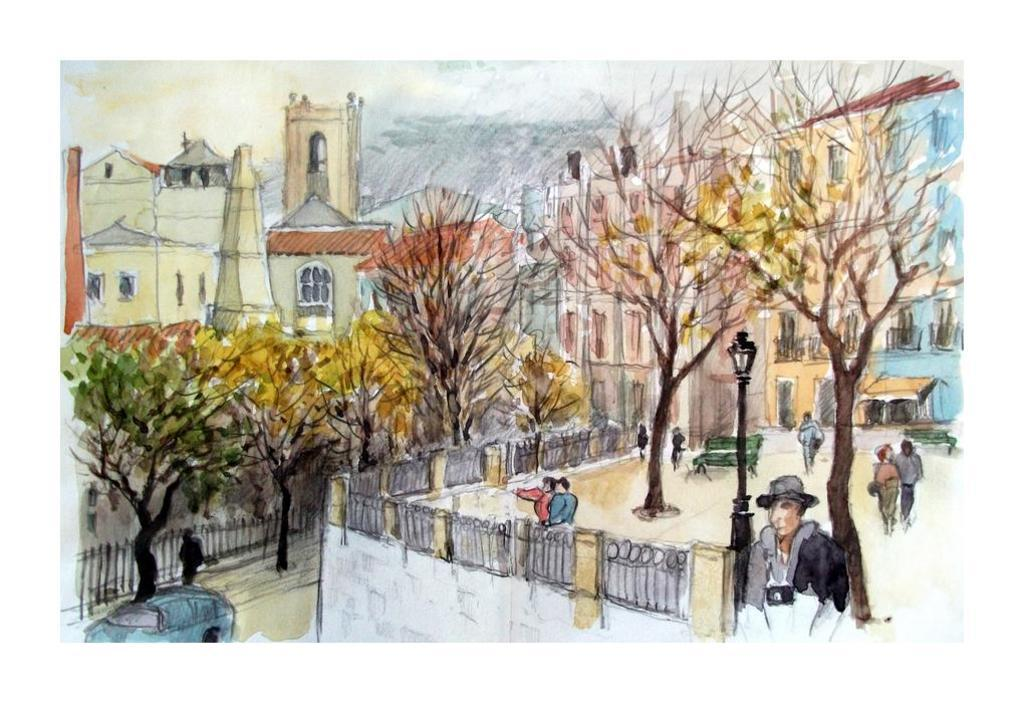What types of subjects are depicted in the painting? The painting contains people, trees, a light pole, a bench, a vehicle, buildings, and a fence. Can you describe the setting of the painting? The painting contains elements of an urban environment, including buildings and a vehicle, as well as natural elements like trees and a fence. What type of structure can be seen in the painting? The painting contains a bench and a light pole, which are both structures. What is the primary mode of transportation depicted in the painting? The painting contains a vehicle, which is the primary mode of transportation depicted. What type of necklace is the person wearing in the painting? There is no necklace visible in the painting; the person is not wearing any jewelry. What type of arch can be seen in the painting? There is no arch present in the painting; it contains a light pole, a bench, a vehicle, buildings, and a fence. 